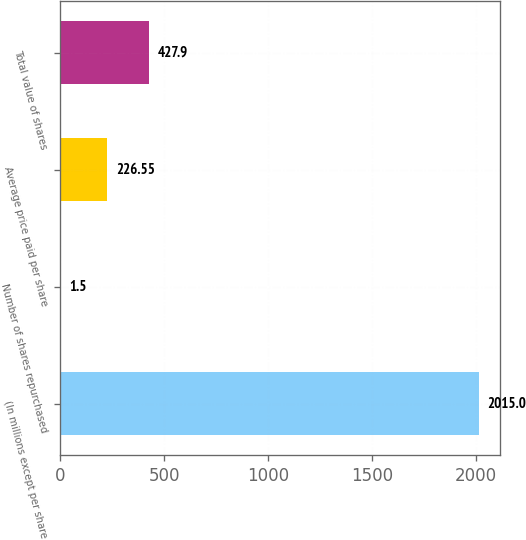<chart> <loc_0><loc_0><loc_500><loc_500><bar_chart><fcel>(In millions except per share<fcel>Number of shares repurchased<fcel>Average price paid per share<fcel>Total value of shares<nl><fcel>2015<fcel>1.5<fcel>226.55<fcel>427.9<nl></chart> 